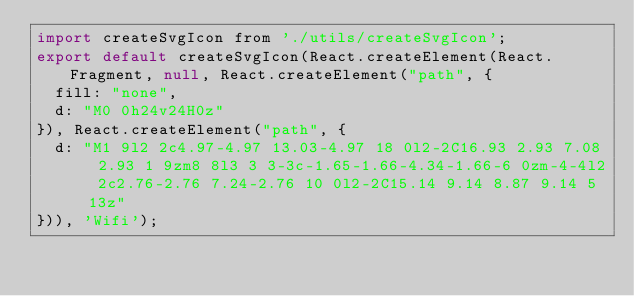Convert code to text. <code><loc_0><loc_0><loc_500><loc_500><_JavaScript_>import createSvgIcon from './utils/createSvgIcon';
export default createSvgIcon(React.createElement(React.Fragment, null, React.createElement("path", {
  fill: "none",
  d: "M0 0h24v24H0z"
}), React.createElement("path", {
  d: "M1 9l2 2c4.97-4.97 13.03-4.97 18 0l2-2C16.93 2.93 7.08 2.93 1 9zm8 8l3 3 3-3c-1.65-1.66-4.34-1.66-6 0zm-4-4l2 2c2.76-2.76 7.24-2.76 10 0l2-2C15.14 9.14 8.87 9.14 5 13z"
})), 'Wifi');</code> 